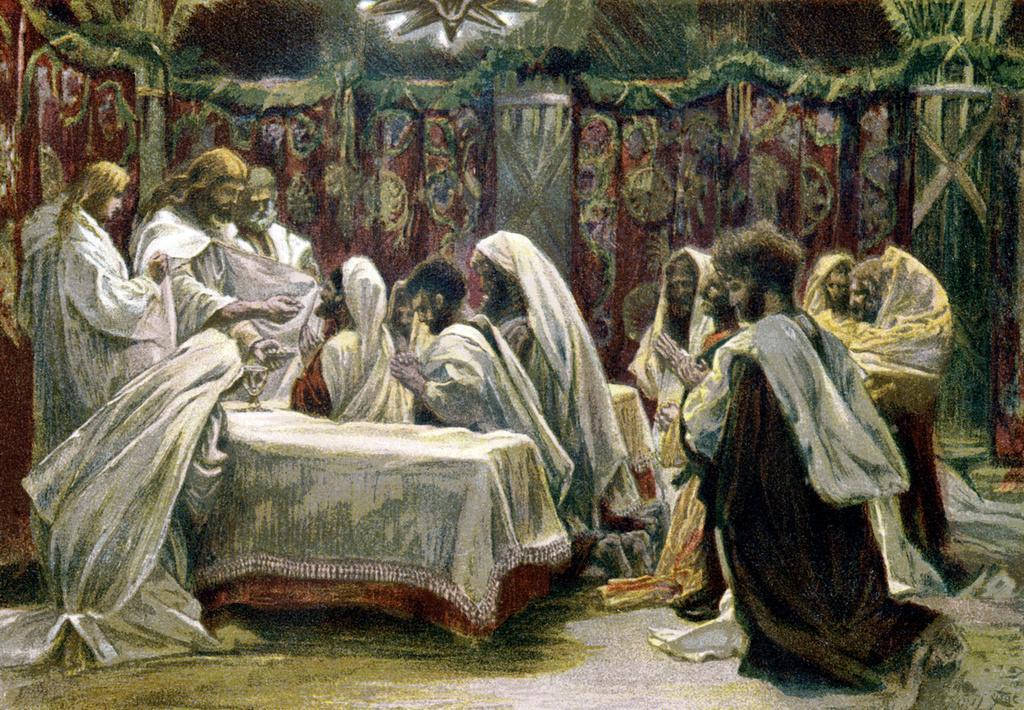Could you give a brief overview of what you see in this image? In this image I can see depiction picture of people. I can also see most of them are wearing white colour dress. 